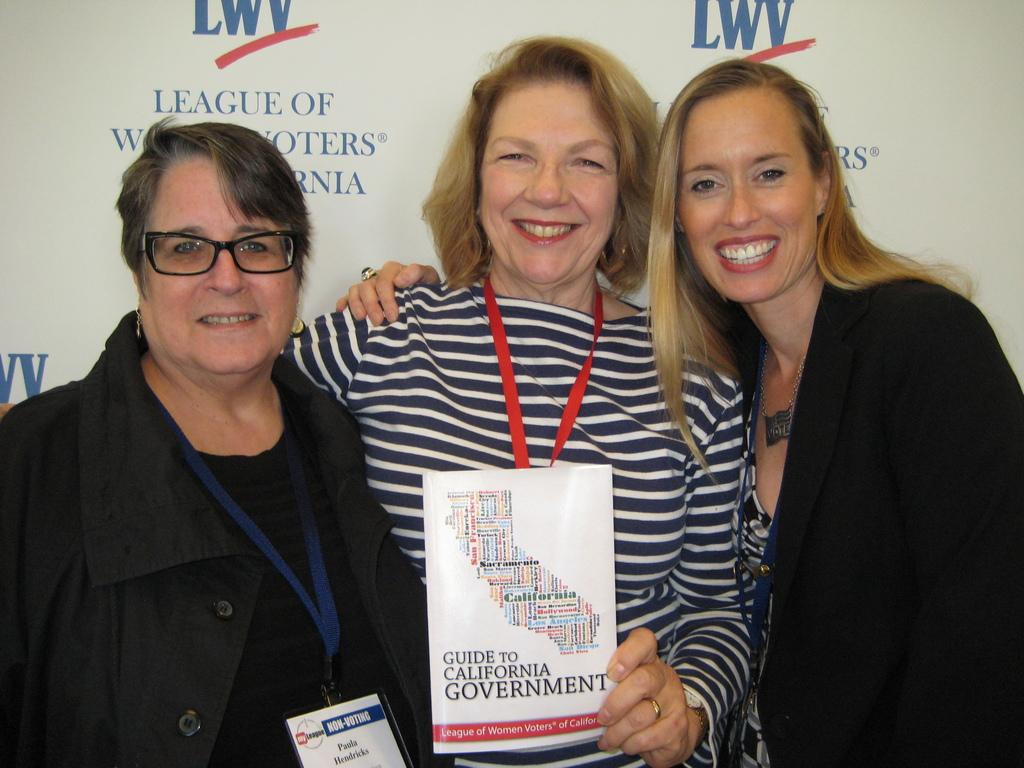What is the main subject of the image? There is a lady standing in the center of the image. What is the lady in the center holding? The lady is holding a pamphlet in her hand. Are there any other people in the image? Yes, there are other ladies on both sides of the central lady. What can be seen in the background of the image? There is a poster in the background area. What type of copper object is being used for digestion in the image? There is no copper object or any reference to digestion in the image. 